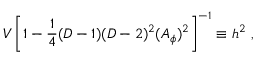<formula> <loc_0><loc_0><loc_500><loc_500>V \left [ 1 - { \frac { 1 } { 4 } } ( D - 1 ) ( D - 2 ) ^ { 2 } ( A _ { \phi } ) ^ { 2 } \right ] ^ { - 1 } \equiv h ^ { 2 } ,</formula> 